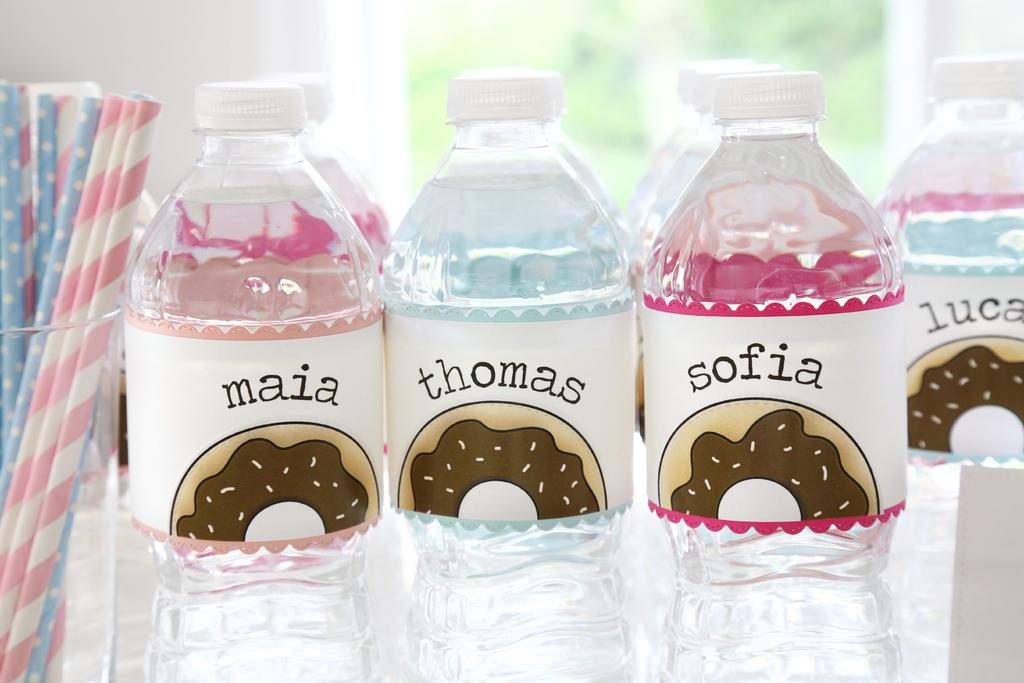<image>
Offer a succinct explanation of the picture presented. Bottles of water labeled maia, thomas, and sofia all have doughnuts on the labels. 